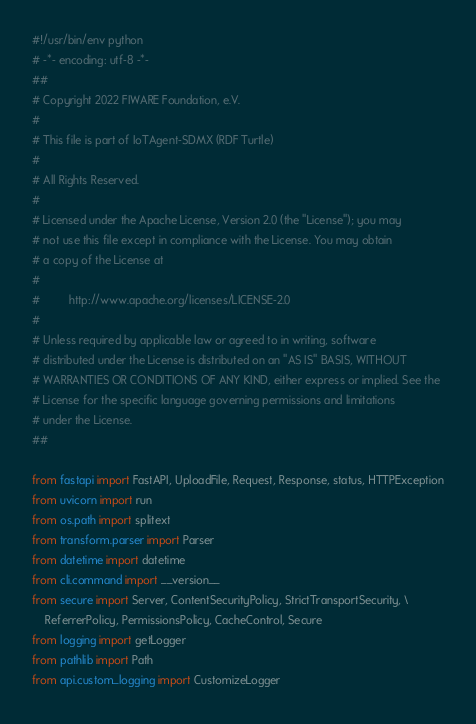<code> <loc_0><loc_0><loc_500><loc_500><_Python_>#!/usr/bin/env python
# -*- encoding: utf-8 -*-
##
# Copyright 2022 FIWARE Foundation, e.V.
#
# This file is part of IoTAgent-SDMX (RDF Turtle)
#
# All Rights Reserved.
#
# Licensed under the Apache License, Version 2.0 (the "License"); you may
# not use this file except in compliance with the License. You may obtain
# a copy of the License at
#
#         http://www.apache.org/licenses/LICENSE-2.0
#
# Unless required by applicable law or agreed to in writing, software
# distributed under the License is distributed on an "AS IS" BASIS, WITHOUT
# WARRANTIES OR CONDITIONS OF ANY KIND, either express or implied. See the
# License for the specific language governing permissions and limitations
# under the License.
##

from fastapi import FastAPI, UploadFile, Request, Response, status, HTTPException
from uvicorn import run
from os.path import splitext
from transform.parser import Parser
from datetime import datetime
from cli.command import __version__
from secure import Server, ContentSecurityPolicy, StrictTransportSecurity, \
    ReferrerPolicy, PermissionsPolicy, CacheControl, Secure
from logging import getLogger
from pathlib import Path
from api.custom_logging import CustomizeLogger</code> 